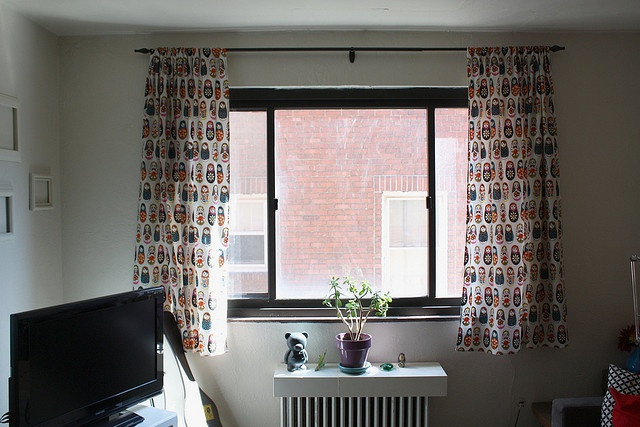Describe the objects in this image and their specific colors. I can see tv in darkgray, black, gray, and white tones, potted plant in darkgray, white, black, and gray tones, couch in darkgray, black, maroon, and gray tones, tennis racket in darkgray, white, black, and gray tones, and teddy bear in darkgray, black, gray, white, and blue tones in this image. 